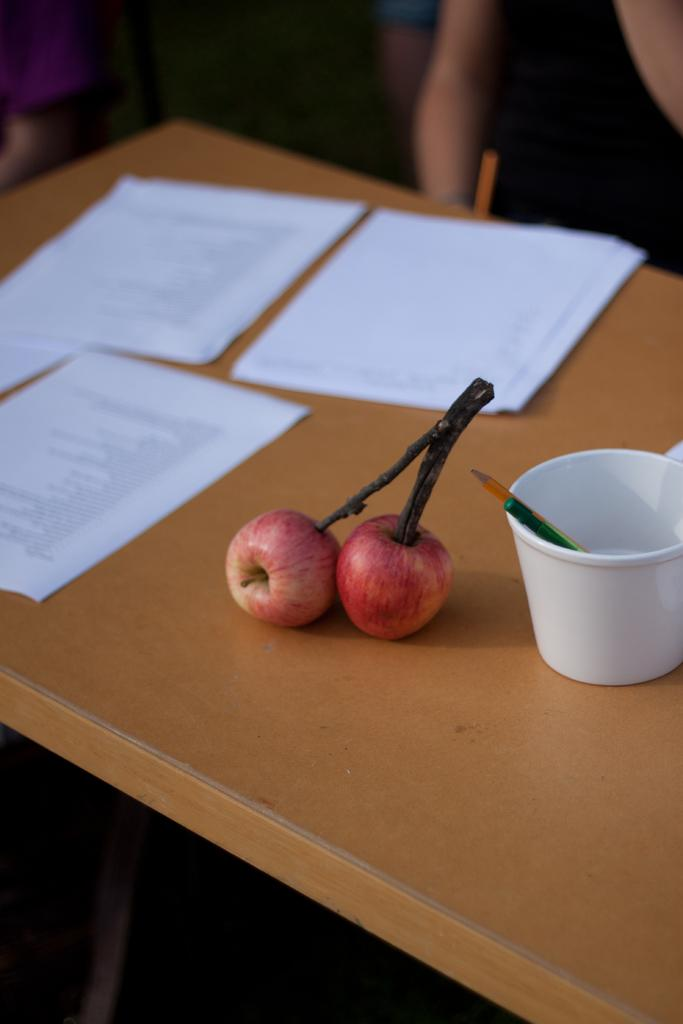What type of furniture is in the image? There is a table in the image. What items can be seen on the table? Papers, a cup, a blade, and apples are present on the table. What is inside the cup on the table? A blade is inside the cup on the table. What rhythm is being played in the background of the image? There is no music or rhythm present in the image; it only features a table with various items on it. 